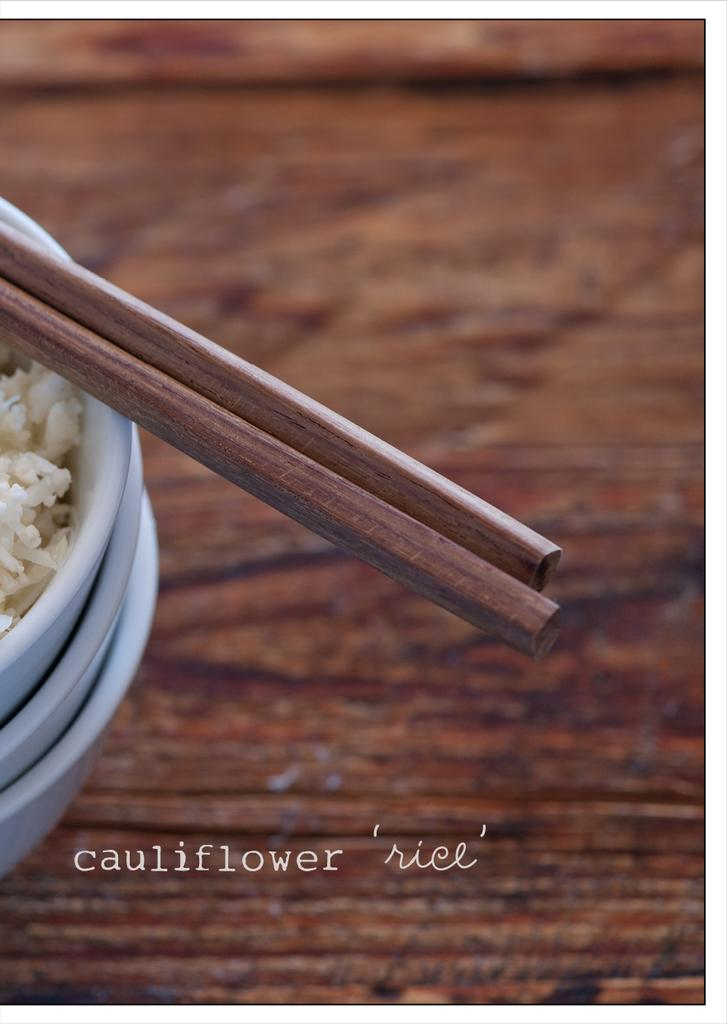What type of table is in the image? There is a wooden table in the image. What is on the wooden table? There are three bowls with food on the table. What utensils are present in the image? A: There are wooden chopsticks in the image. What type of noise can be heard coming from the bowls in the image? There is no noise coming from the bowls in the image. The image is a still representation and does not include any sounds. 